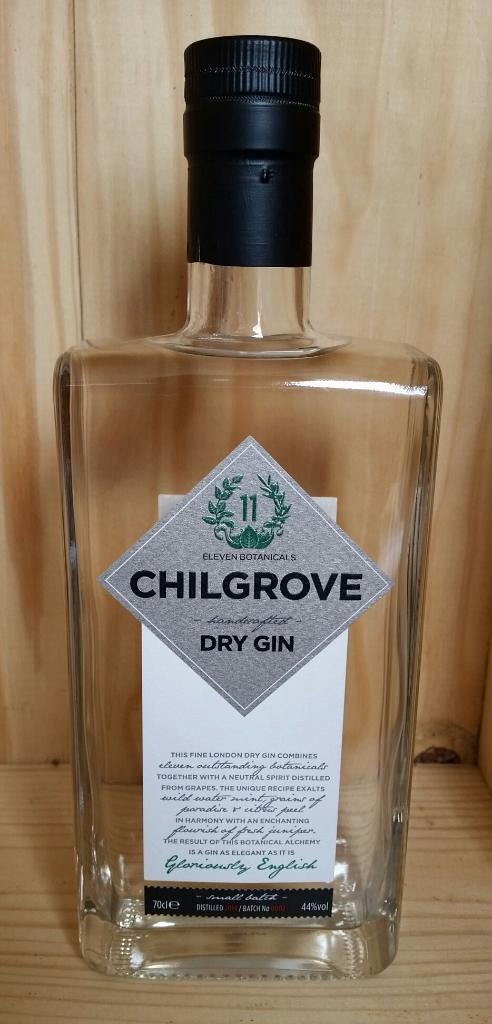<image>
Relay a brief, clear account of the picture shown. A bottle of clear dry gin from the company Chilgrove. 